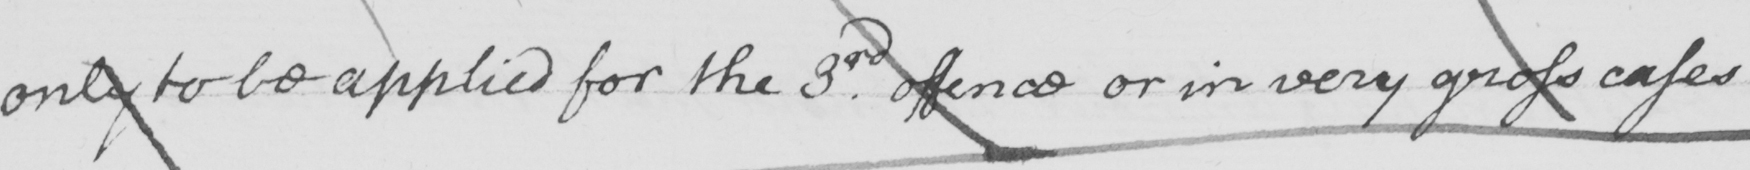Can you read and transcribe this handwriting? only to be applied for the 3rd offence or in very gross cases 